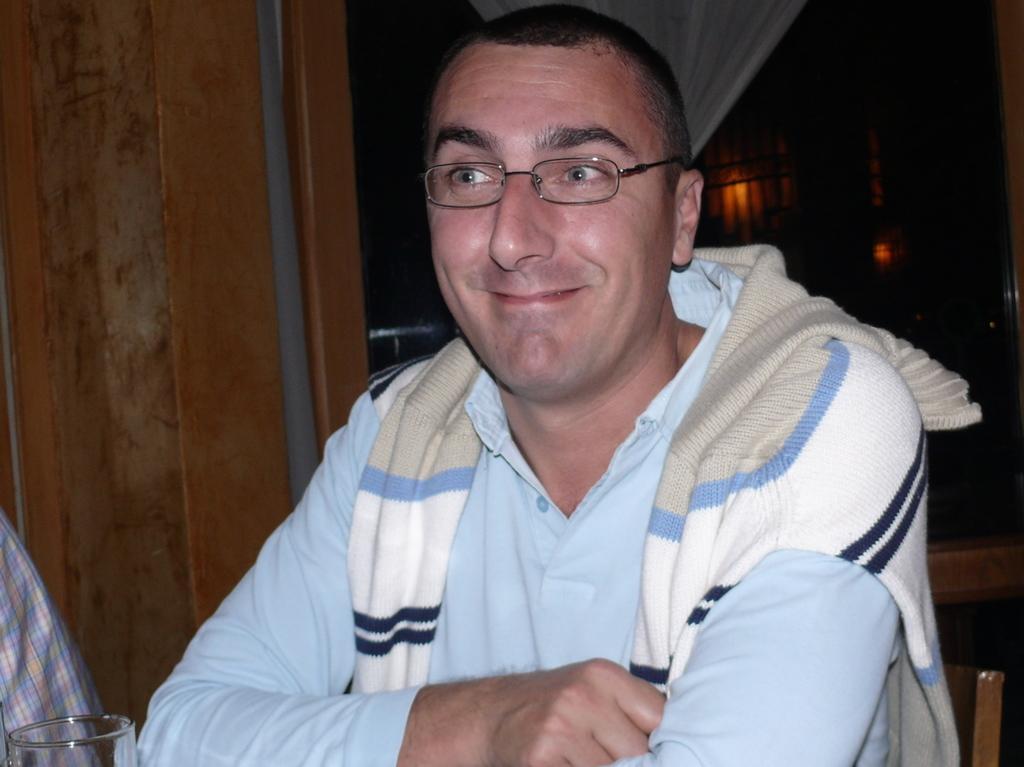How would you summarize this image in a sentence or two? In this image we can see one person with eye glasses, near there is a glass, wooden wall, curtain, a few lights in the background. 